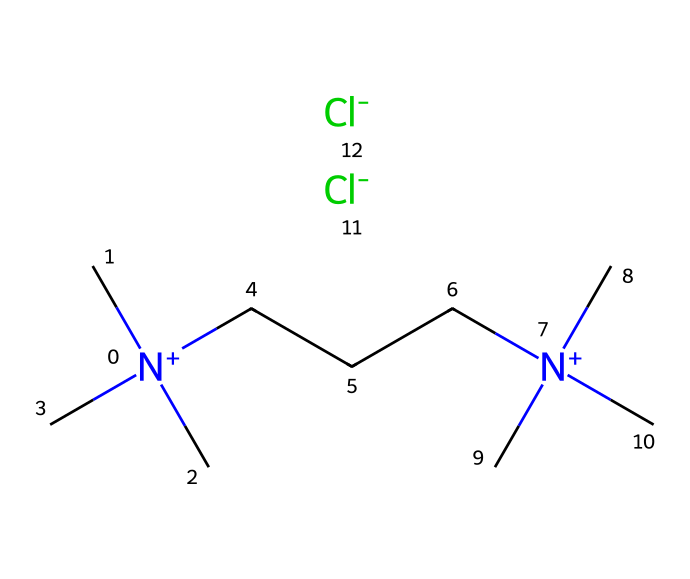What is the total number of carbon atoms in this ionic liquid? Counting from the SMILES, there are three carbon atoms in the three methyl groups attached to nitrogen and seven carbon atoms in the straight chain (CCC) connected to the nitrogen atoms, totaling ten.
Answer: ten How many nitrogen atoms are present in this structure? The structure contains two nitrogen atoms, as indicated by the two [N+] groups appearing in the SMILES.
Answer: two What type of ions are present in this ionic liquid? The SMILES shows two [Cl-] ions at the end, which indicates that the anions in this ionic liquid are chloride ions.
Answer: chloride Which functional groups are indicated by the structure? The nitrogen atoms indicate quaternary ammonium functional groups due to their positive charges and the four substituents (three methyl and one butyl).
Answer: quaternary ammonium What charge does the overall structure possess? The presence of two [Cl-] ions balances the two [N+], leading to an overall neutral structure, indicating no net charge.
Answer: neutral How does the structure contribute to the properties of long-lasting air fresheners? The ionic character and low volatility of the quaternary ammonium groups contribute to the long-lasting aspects, allowing for prolonged release of fragrance without evaporation.
Answer: prolonged release 